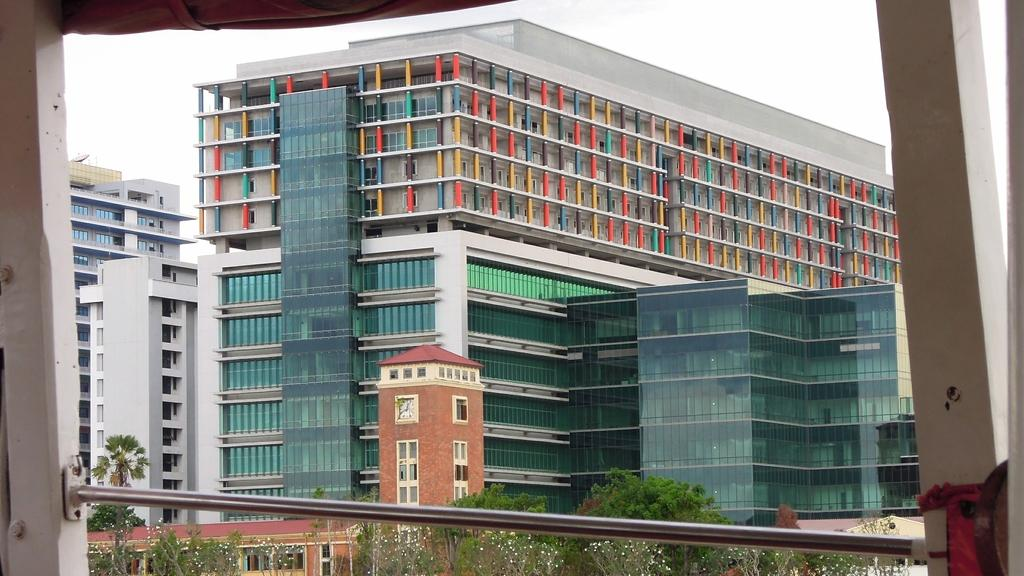What can be seen on the left side of the image? There are roads on the left side of the image. What can be seen on the right side of the image? There are roads on the right side of the image. What is located in the middle of the image? There is a big building in the middle of the image. What type of vegetation is present in the image? There are trees in the image. Can you tell me how many roots are visible in the image? There are no roots present in the image; it features roads, a big building, and trees. Is the image taken on an island? The provided facts do not mention anything about the image being taken on an island, so we cannot definitively answer that question. 